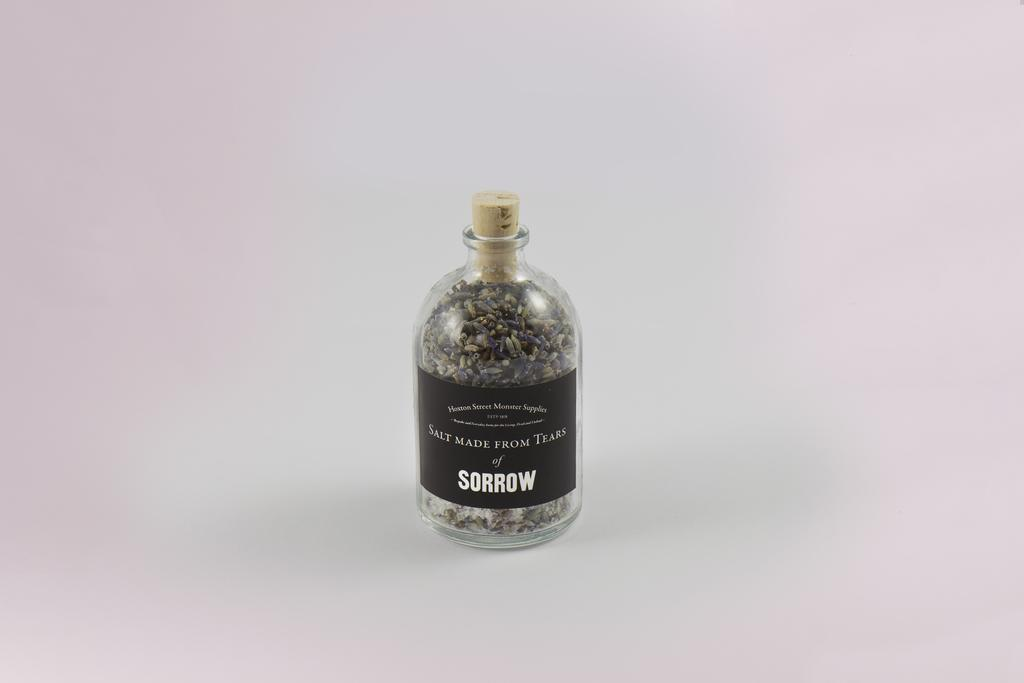<image>
Share a concise interpretation of the image provided. A bottle of Salt Made From Tears of Sorrow sits against a pink background 